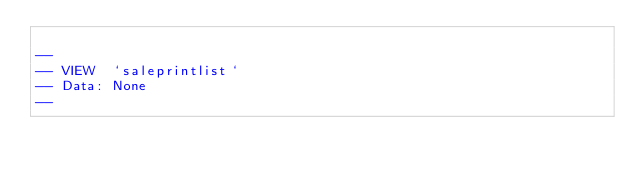Convert code to text. <code><loc_0><loc_0><loc_500><loc_500><_SQL_>
--
-- VIEW  `saleprintlist`
-- Data: None
--

</code> 